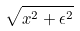<formula> <loc_0><loc_0><loc_500><loc_500>\sqrt { x ^ { 2 } + \epsilon ^ { 2 } }</formula> 